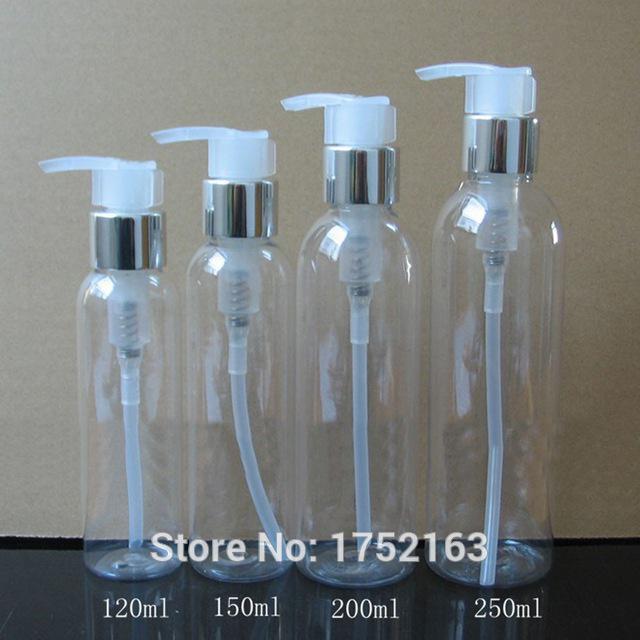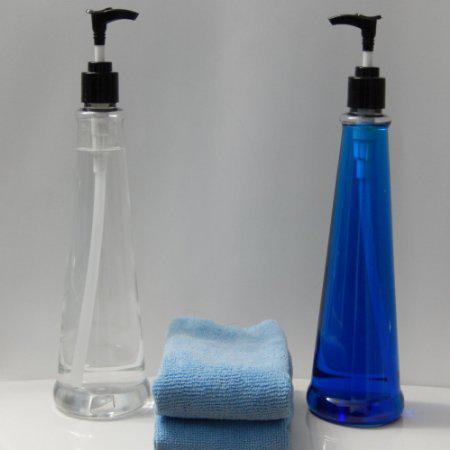The first image is the image on the left, the second image is the image on the right. Examine the images to the left and right. Is the description "There are two bottles total from both images." accurate? Answer yes or no. No. The first image is the image on the left, the second image is the image on the right. For the images shown, is this caption "In one image a canning jar has been accessorized with a metal pump top." true? Answer yes or no. No. 